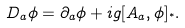<formula> <loc_0><loc_0><loc_500><loc_500>D _ { a } \phi = \partial _ { a } \phi + i g [ A _ { a } , \phi ] _ { ^ { * } } .</formula> 